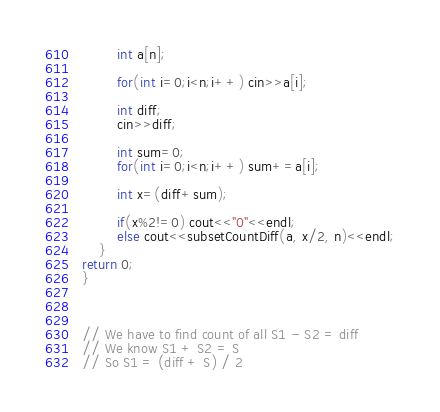Convert code to text. <code><loc_0><loc_0><loc_500><loc_500><_C++_>        int a[n];

        for(int i=0;i<n;i++) cin>>a[i];

        int diff;
        cin>>diff;

        int sum=0;
        for(int i=0;i<n;i++) sum+=a[i];

        int x=(diff+sum);

        if(x%2!=0) cout<<"0"<<endl;
        else cout<<subsetCountDiff(a, x/2, n)<<endl;
    }
return 0;
}



// We have to find count of all S1 - S2 = diff
// We know S1 + S2 = S
// So S1 = (diff + S) / 2
</code> 